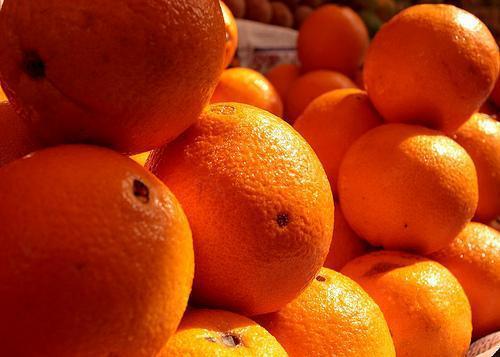How many oranges can you see?
Give a very brief answer. 10. How many people are shown?
Give a very brief answer. 0. 